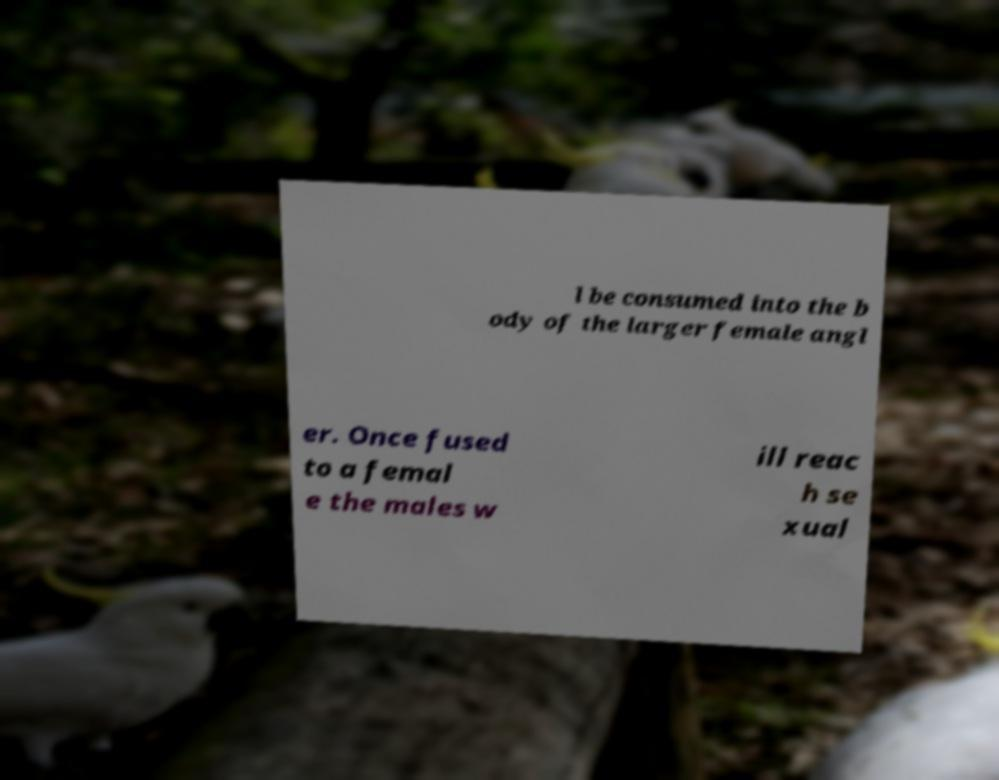I need the written content from this picture converted into text. Can you do that? l be consumed into the b ody of the larger female angl er. Once fused to a femal e the males w ill reac h se xual 